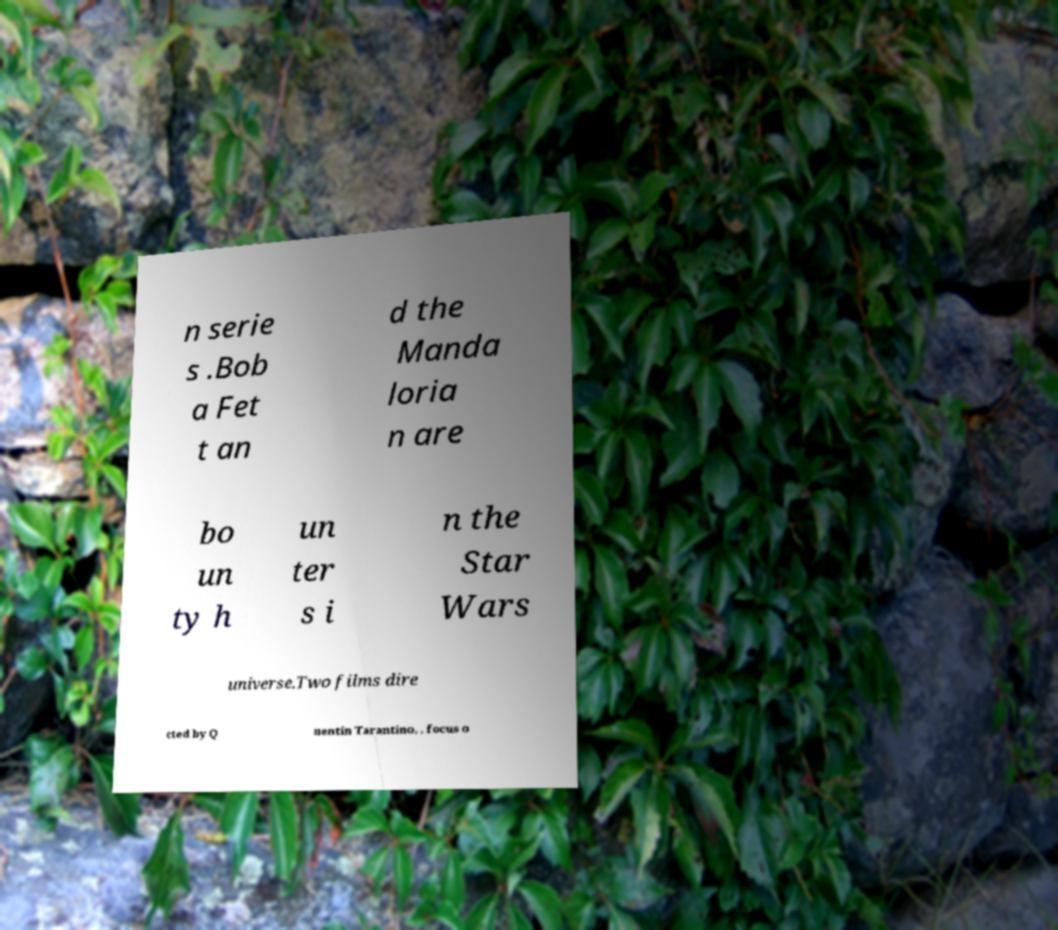What messages or text are displayed in this image? I need them in a readable, typed format. n serie s .Bob a Fet t an d the Manda loria n are bo un ty h un ter s i n the Star Wars universe.Two films dire cted by Q uentin Tarantino, , focus o 